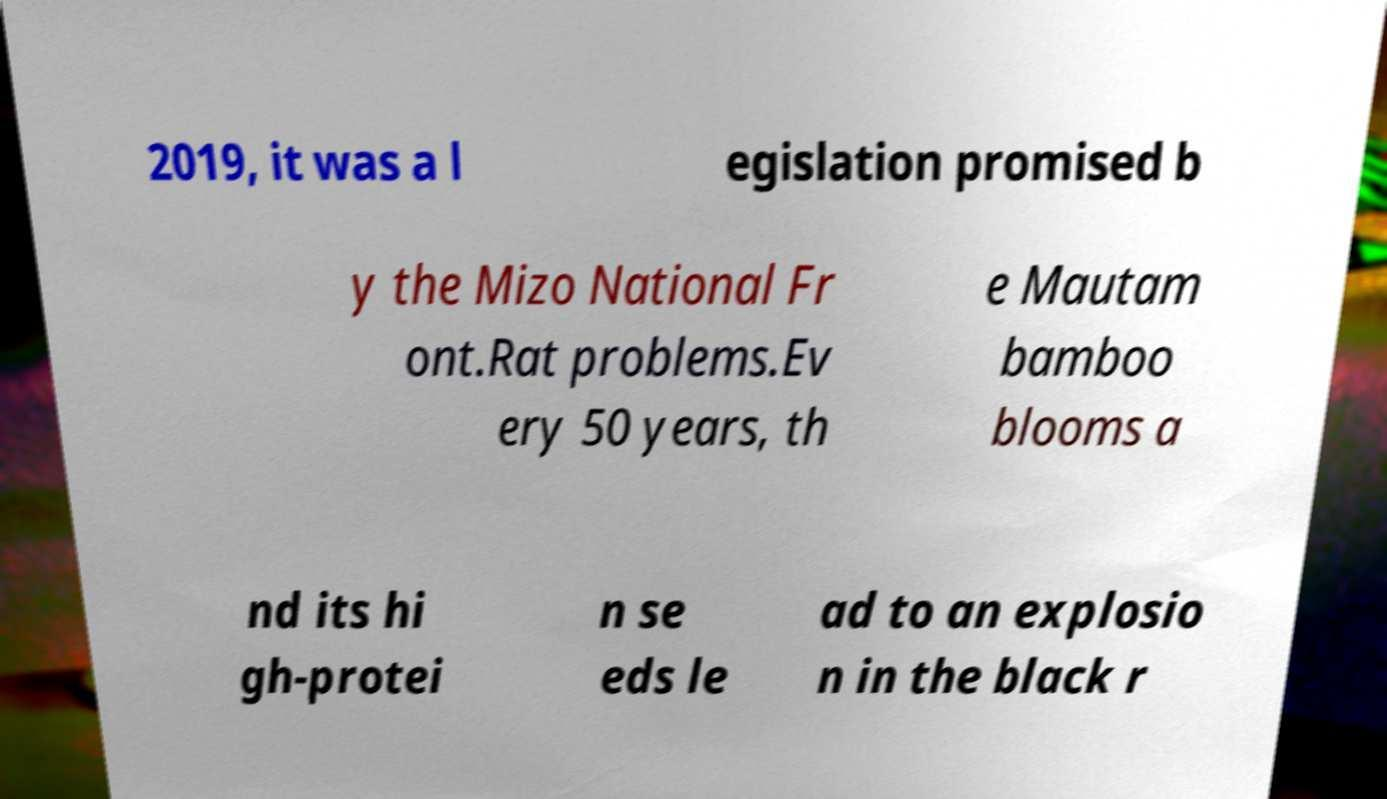Could you extract and type out the text from this image? 2019, it was a l egislation promised b y the Mizo National Fr ont.Rat problems.Ev ery 50 years, th e Mautam bamboo blooms a nd its hi gh-protei n se eds le ad to an explosio n in the black r 